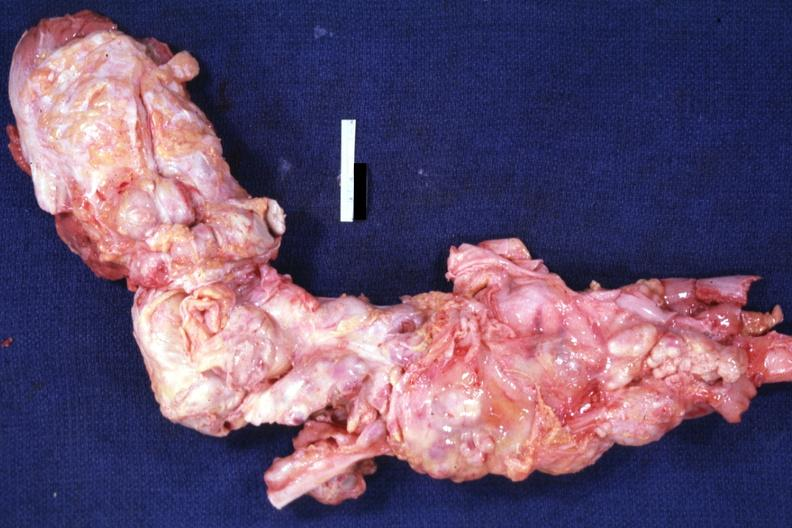s lymph node present?
Answer the question using a single word or phrase. Yes 